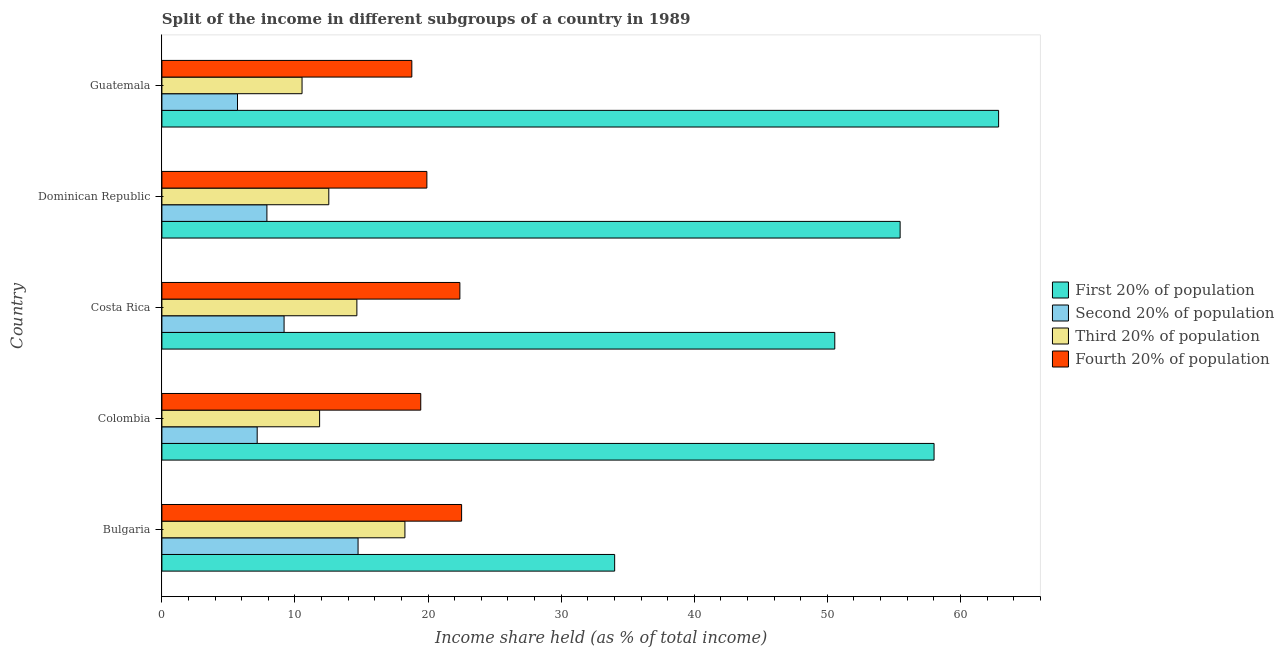How many different coloured bars are there?
Provide a succinct answer. 4. How many groups of bars are there?
Ensure brevity in your answer.  5. How many bars are there on the 4th tick from the top?
Offer a very short reply. 4. What is the label of the 1st group of bars from the top?
Provide a short and direct response. Guatemala. What is the share of the income held by second 20% of the population in Bulgaria?
Offer a terse response. 14.74. Across all countries, what is the maximum share of the income held by third 20% of the population?
Your answer should be very brief. 18.26. Across all countries, what is the minimum share of the income held by fourth 20% of the population?
Your answer should be compact. 18.78. In which country was the share of the income held by first 20% of the population maximum?
Your response must be concise. Guatemala. In which country was the share of the income held by first 20% of the population minimum?
Keep it short and to the point. Bulgaria. What is the total share of the income held by fourth 20% of the population in the graph?
Offer a very short reply. 103.05. What is the difference between the share of the income held by second 20% of the population in Bulgaria and that in Costa Rica?
Ensure brevity in your answer.  5.56. What is the difference between the share of the income held by third 20% of the population in Bulgaria and the share of the income held by fourth 20% of the population in Colombia?
Offer a very short reply. -1.19. What is the average share of the income held by fourth 20% of the population per country?
Keep it short and to the point. 20.61. What is the difference between the share of the income held by third 20% of the population and share of the income held by first 20% of the population in Guatemala?
Keep it short and to the point. -52.34. In how many countries, is the share of the income held by fourth 20% of the population greater than 44 %?
Give a very brief answer. 0. What is the ratio of the share of the income held by third 20% of the population in Dominican Republic to that in Guatemala?
Provide a short and direct response. 1.19. Is the share of the income held by first 20% of the population in Bulgaria less than that in Colombia?
Your answer should be very brief. Yes. What is the difference between the highest and the second highest share of the income held by second 20% of the population?
Your answer should be compact. 5.56. What is the difference between the highest and the lowest share of the income held by third 20% of the population?
Ensure brevity in your answer.  7.73. Is the sum of the share of the income held by first 20% of the population in Bulgaria and Colombia greater than the maximum share of the income held by third 20% of the population across all countries?
Offer a terse response. Yes. What does the 1st bar from the top in Bulgaria represents?
Make the answer very short. Fourth 20% of population. What does the 4th bar from the bottom in Colombia represents?
Your response must be concise. Fourth 20% of population. How many countries are there in the graph?
Offer a terse response. 5. What is the difference between two consecutive major ticks on the X-axis?
Offer a terse response. 10. Does the graph contain grids?
Your answer should be compact. No. Where does the legend appear in the graph?
Offer a very short reply. Center right. What is the title of the graph?
Give a very brief answer. Split of the income in different subgroups of a country in 1989. What is the label or title of the X-axis?
Your answer should be very brief. Income share held (as % of total income). What is the label or title of the Y-axis?
Offer a terse response. Country. What is the Income share held (as % of total income) of First 20% of population in Bulgaria?
Offer a terse response. 34.02. What is the Income share held (as % of total income) in Second 20% of population in Bulgaria?
Offer a terse response. 14.74. What is the Income share held (as % of total income) of Third 20% of population in Bulgaria?
Offer a very short reply. 18.26. What is the Income share held (as % of total income) of Fourth 20% of population in Bulgaria?
Your answer should be compact. 22.52. What is the Income share held (as % of total income) of First 20% of population in Colombia?
Your answer should be very brief. 58.02. What is the Income share held (as % of total income) in Second 20% of population in Colombia?
Provide a succinct answer. 7.16. What is the Income share held (as % of total income) of Third 20% of population in Colombia?
Your answer should be compact. 11.85. What is the Income share held (as % of total income) of Fourth 20% of population in Colombia?
Provide a succinct answer. 19.45. What is the Income share held (as % of total income) of First 20% of population in Costa Rica?
Your response must be concise. 50.56. What is the Income share held (as % of total income) in Second 20% of population in Costa Rica?
Your answer should be very brief. 9.18. What is the Income share held (as % of total income) in Third 20% of population in Costa Rica?
Your answer should be compact. 14.65. What is the Income share held (as % of total income) of Fourth 20% of population in Costa Rica?
Your answer should be compact. 22.39. What is the Income share held (as % of total income) in First 20% of population in Dominican Republic?
Keep it short and to the point. 55.47. What is the Income share held (as % of total income) of Second 20% of population in Dominican Republic?
Offer a terse response. 7.89. What is the Income share held (as % of total income) of Third 20% of population in Dominican Republic?
Ensure brevity in your answer.  12.54. What is the Income share held (as % of total income) in Fourth 20% of population in Dominican Republic?
Provide a short and direct response. 19.91. What is the Income share held (as % of total income) of First 20% of population in Guatemala?
Your response must be concise. 62.87. What is the Income share held (as % of total income) of Second 20% of population in Guatemala?
Give a very brief answer. 5.68. What is the Income share held (as % of total income) of Third 20% of population in Guatemala?
Keep it short and to the point. 10.53. What is the Income share held (as % of total income) of Fourth 20% of population in Guatemala?
Ensure brevity in your answer.  18.78. Across all countries, what is the maximum Income share held (as % of total income) in First 20% of population?
Keep it short and to the point. 62.87. Across all countries, what is the maximum Income share held (as % of total income) in Second 20% of population?
Provide a succinct answer. 14.74. Across all countries, what is the maximum Income share held (as % of total income) in Third 20% of population?
Your response must be concise. 18.26. Across all countries, what is the maximum Income share held (as % of total income) of Fourth 20% of population?
Your answer should be very brief. 22.52. Across all countries, what is the minimum Income share held (as % of total income) of First 20% of population?
Give a very brief answer. 34.02. Across all countries, what is the minimum Income share held (as % of total income) in Second 20% of population?
Your response must be concise. 5.68. Across all countries, what is the minimum Income share held (as % of total income) in Third 20% of population?
Your response must be concise. 10.53. Across all countries, what is the minimum Income share held (as % of total income) in Fourth 20% of population?
Provide a short and direct response. 18.78. What is the total Income share held (as % of total income) of First 20% of population in the graph?
Your answer should be compact. 260.94. What is the total Income share held (as % of total income) of Second 20% of population in the graph?
Provide a short and direct response. 44.65. What is the total Income share held (as % of total income) in Third 20% of population in the graph?
Keep it short and to the point. 67.83. What is the total Income share held (as % of total income) of Fourth 20% of population in the graph?
Your response must be concise. 103.05. What is the difference between the Income share held (as % of total income) of Second 20% of population in Bulgaria and that in Colombia?
Provide a succinct answer. 7.58. What is the difference between the Income share held (as % of total income) in Third 20% of population in Bulgaria and that in Colombia?
Give a very brief answer. 6.41. What is the difference between the Income share held (as % of total income) of Fourth 20% of population in Bulgaria and that in Colombia?
Your answer should be very brief. 3.07. What is the difference between the Income share held (as % of total income) in First 20% of population in Bulgaria and that in Costa Rica?
Your response must be concise. -16.54. What is the difference between the Income share held (as % of total income) of Second 20% of population in Bulgaria and that in Costa Rica?
Ensure brevity in your answer.  5.56. What is the difference between the Income share held (as % of total income) in Third 20% of population in Bulgaria and that in Costa Rica?
Ensure brevity in your answer.  3.61. What is the difference between the Income share held (as % of total income) of Fourth 20% of population in Bulgaria and that in Costa Rica?
Make the answer very short. 0.13. What is the difference between the Income share held (as % of total income) of First 20% of population in Bulgaria and that in Dominican Republic?
Offer a terse response. -21.45. What is the difference between the Income share held (as % of total income) in Second 20% of population in Bulgaria and that in Dominican Republic?
Your response must be concise. 6.85. What is the difference between the Income share held (as % of total income) of Third 20% of population in Bulgaria and that in Dominican Republic?
Give a very brief answer. 5.72. What is the difference between the Income share held (as % of total income) in Fourth 20% of population in Bulgaria and that in Dominican Republic?
Your response must be concise. 2.61. What is the difference between the Income share held (as % of total income) in First 20% of population in Bulgaria and that in Guatemala?
Make the answer very short. -28.85. What is the difference between the Income share held (as % of total income) of Second 20% of population in Bulgaria and that in Guatemala?
Keep it short and to the point. 9.06. What is the difference between the Income share held (as % of total income) of Third 20% of population in Bulgaria and that in Guatemala?
Your answer should be very brief. 7.73. What is the difference between the Income share held (as % of total income) in Fourth 20% of population in Bulgaria and that in Guatemala?
Keep it short and to the point. 3.74. What is the difference between the Income share held (as % of total income) in First 20% of population in Colombia and that in Costa Rica?
Ensure brevity in your answer.  7.46. What is the difference between the Income share held (as % of total income) of Second 20% of population in Colombia and that in Costa Rica?
Offer a very short reply. -2.02. What is the difference between the Income share held (as % of total income) of Third 20% of population in Colombia and that in Costa Rica?
Offer a very short reply. -2.8. What is the difference between the Income share held (as % of total income) in Fourth 20% of population in Colombia and that in Costa Rica?
Make the answer very short. -2.94. What is the difference between the Income share held (as % of total income) in First 20% of population in Colombia and that in Dominican Republic?
Provide a succinct answer. 2.55. What is the difference between the Income share held (as % of total income) of Second 20% of population in Colombia and that in Dominican Republic?
Ensure brevity in your answer.  -0.73. What is the difference between the Income share held (as % of total income) in Third 20% of population in Colombia and that in Dominican Republic?
Provide a succinct answer. -0.69. What is the difference between the Income share held (as % of total income) in Fourth 20% of population in Colombia and that in Dominican Republic?
Keep it short and to the point. -0.46. What is the difference between the Income share held (as % of total income) in First 20% of population in Colombia and that in Guatemala?
Provide a succinct answer. -4.85. What is the difference between the Income share held (as % of total income) of Second 20% of population in Colombia and that in Guatemala?
Provide a succinct answer. 1.48. What is the difference between the Income share held (as % of total income) in Third 20% of population in Colombia and that in Guatemala?
Keep it short and to the point. 1.32. What is the difference between the Income share held (as % of total income) of Fourth 20% of population in Colombia and that in Guatemala?
Your answer should be very brief. 0.67. What is the difference between the Income share held (as % of total income) in First 20% of population in Costa Rica and that in Dominican Republic?
Offer a very short reply. -4.91. What is the difference between the Income share held (as % of total income) of Second 20% of population in Costa Rica and that in Dominican Republic?
Your response must be concise. 1.29. What is the difference between the Income share held (as % of total income) of Third 20% of population in Costa Rica and that in Dominican Republic?
Keep it short and to the point. 2.11. What is the difference between the Income share held (as % of total income) of Fourth 20% of population in Costa Rica and that in Dominican Republic?
Your answer should be compact. 2.48. What is the difference between the Income share held (as % of total income) of First 20% of population in Costa Rica and that in Guatemala?
Your answer should be very brief. -12.31. What is the difference between the Income share held (as % of total income) of Second 20% of population in Costa Rica and that in Guatemala?
Your answer should be compact. 3.5. What is the difference between the Income share held (as % of total income) in Third 20% of population in Costa Rica and that in Guatemala?
Offer a terse response. 4.12. What is the difference between the Income share held (as % of total income) of Fourth 20% of population in Costa Rica and that in Guatemala?
Your answer should be compact. 3.61. What is the difference between the Income share held (as % of total income) in First 20% of population in Dominican Republic and that in Guatemala?
Your response must be concise. -7.4. What is the difference between the Income share held (as % of total income) in Second 20% of population in Dominican Republic and that in Guatemala?
Make the answer very short. 2.21. What is the difference between the Income share held (as % of total income) of Third 20% of population in Dominican Republic and that in Guatemala?
Offer a terse response. 2.01. What is the difference between the Income share held (as % of total income) in Fourth 20% of population in Dominican Republic and that in Guatemala?
Offer a very short reply. 1.13. What is the difference between the Income share held (as % of total income) of First 20% of population in Bulgaria and the Income share held (as % of total income) of Second 20% of population in Colombia?
Offer a very short reply. 26.86. What is the difference between the Income share held (as % of total income) of First 20% of population in Bulgaria and the Income share held (as % of total income) of Third 20% of population in Colombia?
Your answer should be very brief. 22.17. What is the difference between the Income share held (as % of total income) in First 20% of population in Bulgaria and the Income share held (as % of total income) in Fourth 20% of population in Colombia?
Give a very brief answer. 14.57. What is the difference between the Income share held (as % of total income) in Second 20% of population in Bulgaria and the Income share held (as % of total income) in Third 20% of population in Colombia?
Ensure brevity in your answer.  2.89. What is the difference between the Income share held (as % of total income) in Second 20% of population in Bulgaria and the Income share held (as % of total income) in Fourth 20% of population in Colombia?
Offer a very short reply. -4.71. What is the difference between the Income share held (as % of total income) of Third 20% of population in Bulgaria and the Income share held (as % of total income) of Fourth 20% of population in Colombia?
Your answer should be compact. -1.19. What is the difference between the Income share held (as % of total income) in First 20% of population in Bulgaria and the Income share held (as % of total income) in Second 20% of population in Costa Rica?
Give a very brief answer. 24.84. What is the difference between the Income share held (as % of total income) of First 20% of population in Bulgaria and the Income share held (as % of total income) of Third 20% of population in Costa Rica?
Your response must be concise. 19.37. What is the difference between the Income share held (as % of total income) in First 20% of population in Bulgaria and the Income share held (as % of total income) in Fourth 20% of population in Costa Rica?
Your answer should be very brief. 11.63. What is the difference between the Income share held (as % of total income) of Second 20% of population in Bulgaria and the Income share held (as % of total income) of Third 20% of population in Costa Rica?
Offer a terse response. 0.09. What is the difference between the Income share held (as % of total income) in Second 20% of population in Bulgaria and the Income share held (as % of total income) in Fourth 20% of population in Costa Rica?
Provide a short and direct response. -7.65. What is the difference between the Income share held (as % of total income) in Third 20% of population in Bulgaria and the Income share held (as % of total income) in Fourth 20% of population in Costa Rica?
Your answer should be compact. -4.13. What is the difference between the Income share held (as % of total income) in First 20% of population in Bulgaria and the Income share held (as % of total income) in Second 20% of population in Dominican Republic?
Ensure brevity in your answer.  26.13. What is the difference between the Income share held (as % of total income) of First 20% of population in Bulgaria and the Income share held (as % of total income) of Third 20% of population in Dominican Republic?
Your answer should be very brief. 21.48. What is the difference between the Income share held (as % of total income) of First 20% of population in Bulgaria and the Income share held (as % of total income) of Fourth 20% of population in Dominican Republic?
Ensure brevity in your answer.  14.11. What is the difference between the Income share held (as % of total income) of Second 20% of population in Bulgaria and the Income share held (as % of total income) of Third 20% of population in Dominican Republic?
Your answer should be compact. 2.2. What is the difference between the Income share held (as % of total income) in Second 20% of population in Bulgaria and the Income share held (as % of total income) in Fourth 20% of population in Dominican Republic?
Provide a short and direct response. -5.17. What is the difference between the Income share held (as % of total income) in Third 20% of population in Bulgaria and the Income share held (as % of total income) in Fourth 20% of population in Dominican Republic?
Provide a short and direct response. -1.65. What is the difference between the Income share held (as % of total income) of First 20% of population in Bulgaria and the Income share held (as % of total income) of Second 20% of population in Guatemala?
Make the answer very short. 28.34. What is the difference between the Income share held (as % of total income) in First 20% of population in Bulgaria and the Income share held (as % of total income) in Third 20% of population in Guatemala?
Give a very brief answer. 23.49. What is the difference between the Income share held (as % of total income) of First 20% of population in Bulgaria and the Income share held (as % of total income) of Fourth 20% of population in Guatemala?
Make the answer very short. 15.24. What is the difference between the Income share held (as % of total income) of Second 20% of population in Bulgaria and the Income share held (as % of total income) of Third 20% of population in Guatemala?
Offer a very short reply. 4.21. What is the difference between the Income share held (as % of total income) in Second 20% of population in Bulgaria and the Income share held (as % of total income) in Fourth 20% of population in Guatemala?
Provide a short and direct response. -4.04. What is the difference between the Income share held (as % of total income) in Third 20% of population in Bulgaria and the Income share held (as % of total income) in Fourth 20% of population in Guatemala?
Make the answer very short. -0.52. What is the difference between the Income share held (as % of total income) of First 20% of population in Colombia and the Income share held (as % of total income) of Second 20% of population in Costa Rica?
Ensure brevity in your answer.  48.84. What is the difference between the Income share held (as % of total income) of First 20% of population in Colombia and the Income share held (as % of total income) of Third 20% of population in Costa Rica?
Provide a short and direct response. 43.37. What is the difference between the Income share held (as % of total income) in First 20% of population in Colombia and the Income share held (as % of total income) in Fourth 20% of population in Costa Rica?
Ensure brevity in your answer.  35.63. What is the difference between the Income share held (as % of total income) in Second 20% of population in Colombia and the Income share held (as % of total income) in Third 20% of population in Costa Rica?
Give a very brief answer. -7.49. What is the difference between the Income share held (as % of total income) of Second 20% of population in Colombia and the Income share held (as % of total income) of Fourth 20% of population in Costa Rica?
Give a very brief answer. -15.23. What is the difference between the Income share held (as % of total income) in Third 20% of population in Colombia and the Income share held (as % of total income) in Fourth 20% of population in Costa Rica?
Provide a short and direct response. -10.54. What is the difference between the Income share held (as % of total income) in First 20% of population in Colombia and the Income share held (as % of total income) in Second 20% of population in Dominican Republic?
Offer a terse response. 50.13. What is the difference between the Income share held (as % of total income) in First 20% of population in Colombia and the Income share held (as % of total income) in Third 20% of population in Dominican Republic?
Keep it short and to the point. 45.48. What is the difference between the Income share held (as % of total income) in First 20% of population in Colombia and the Income share held (as % of total income) in Fourth 20% of population in Dominican Republic?
Provide a short and direct response. 38.11. What is the difference between the Income share held (as % of total income) in Second 20% of population in Colombia and the Income share held (as % of total income) in Third 20% of population in Dominican Republic?
Your answer should be compact. -5.38. What is the difference between the Income share held (as % of total income) of Second 20% of population in Colombia and the Income share held (as % of total income) of Fourth 20% of population in Dominican Republic?
Give a very brief answer. -12.75. What is the difference between the Income share held (as % of total income) of Third 20% of population in Colombia and the Income share held (as % of total income) of Fourth 20% of population in Dominican Republic?
Make the answer very short. -8.06. What is the difference between the Income share held (as % of total income) in First 20% of population in Colombia and the Income share held (as % of total income) in Second 20% of population in Guatemala?
Your response must be concise. 52.34. What is the difference between the Income share held (as % of total income) in First 20% of population in Colombia and the Income share held (as % of total income) in Third 20% of population in Guatemala?
Your answer should be very brief. 47.49. What is the difference between the Income share held (as % of total income) in First 20% of population in Colombia and the Income share held (as % of total income) in Fourth 20% of population in Guatemala?
Offer a terse response. 39.24. What is the difference between the Income share held (as % of total income) in Second 20% of population in Colombia and the Income share held (as % of total income) in Third 20% of population in Guatemala?
Give a very brief answer. -3.37. What is the difference between the Income share held (as % of total income) of Second 20% of population in Colombia and the Income share held (as % of total income) of Fourth 20% of population in Guatemala?
Your response must be concise. -11.62. What is the difference between the Income share held (as % of total income) in Third 20% of population in Colombia and the Income share held (as % of total income) in Fourth 20% of population in Guatemala?
Your answer should be very brief. -6.93. What is the difference between the Income share held (as % of total income) in First 20% of population in Costa Rica and the Income share held (as % of total income) in Second 20% of population in Dominican Republic?
Provide a short and direct response. 42.67. What is the difference between the Income share held (as % of total income) of First 20% of population in Costa Rica and the Income share held (as % of total income) of Third 20% of population in Dominican Republic?
Your answer should be very brief. 38.02. What is the difference between the Income share held (as % of total income) in First 20% of population in Costa Rica and the Income share held (as % of total income) in Fourth 20% of population in Dominican Republic?
Ensure brevity in your answer.  30.65. What is the difference between the Income share held (as % of total income) of Second 20% of population in Costa Rica and the Income share held (as % of total income) of Third 20% of population in Dominican Republic?
Your answer should be compact. -3.36. What is the difference between the Income share held (as % of total income) of Second 20% of population in Costa Rica and the Income share held (as % of total income) of Fourth 20% of population in Dominican Republic?
Your response must be concise. -10.73. What is the difference between the Income share held (as % of total income) of Third 20% of population in Costa Rica and the Income share held (as % of total income) of Fourth 20% of population in Dominican Republic?
Your answer should be very brief. -5.26. What is the difference between the Income share held (as % of total income) of First 20% of population in Costa Rica and the Income share held (as % of total income) of Second 20% of population in Guatemala?
Provide a short and direct response. 44.88. What is the difference between the Income share held (as % of total income) in First 20% of population in Costa Rica and the Income share held (as % of total income) in Third 20% of population in Guatemala?
Give a very brief answer. 40.03. What is the difference between the Income share held (as % of total income) of First 20% of population in Costa Rica and the Income share held (as % of total income) of Fourth 20% of population in Guatemala?
Offer a very short reply. 31.78. What is the difference between the Income share held (as % of total income) of Second 20% of population in Costa Rica and the Income share held (as % of total income) of Third 20% of population in Guatemala?
Give a very brief answer. -1.35. What is the difference between the Income share held (as % of total income) in Second 20% of population in Costa Rica and the Income share held (as % of total income) in Fourth 20% of population in Guatemala?
Offer a terse response. -9.6. What is the difference between the Income share held (as % of total income) of Third 20% of population in Costa Rica and the Income share held (as % of total income) of Fourth 20% of population in Guatemala?
Offer a terse response. -4.13. What is the difference between the Income share held (as % of total income) in First 20% of population in Dominican Republic and the Income share held (as % of total income) in Second 20% of population in Guatemala?
Make the answer very short. 49.79. What is the difference between the Income share held (as % of total income) of First 20% of population in Dominican Republic and the Income share held (as % of total income) of Third 20% of population in Guatemala?
Give a very brief answer. 44.94. What is the difference between the Income share held (as % of total income) of First 20% of population in Dominican Republic and the Income share held (as % of total income) of Fourth 20% of population in Guatemala?
Offer a terse response. 36.69. What is the difference between the Income share held (as % of total income) of Second 20% of population in Dominican Republic and the Income share held (as % of total income) of Third 20% of population in Guatemala?
Give a very brief answer. -2.64. What is the difference between the Income share held (as % of total income) of Second 20% of population in Dominican Republic and the Income share held (as % of total income) of Fourth 20% of population in Guatemala?
Provide a short and direct response. -10.89. What is the difference between the Income share held (as % of total income) in Third 20% of population in Dominican Republic and the Income share held (as % of total income) in Fourth 20% of population in Guatemala?
Provide a succinct answer. -6.24. What is the average Income share held (as % of total income) in First 20% of population per country?
Ensure brevity in your answer.  52.19. What is the average Income share held (as % of total income) in Second 20% of population per country?
Offer a terse response. 8.93. What is the average Income share held (as % of total income) of Third 20% of population per country?
Make the answer very short. 13.57. What is the average Income share held (as % of total income) of Fourth 20% of population per country?
Make the answer very short. 20.61. What is the difference between the Income share held (as % of total income) in First 20% of population and Income share held (as % of total income) in Second 20% of population in Bulgaria?
Offer a terse response. 19.28. What is the difference between the Income share held (as % of total income) in First 20% of population and Income share held (as % of total income) in Third 20% of population in Bulgaria?
Your answer should be compact. 15.76. What is the difference between the Income share held (as % of total income) of First 20% of population and Income share held (as % of total income) of Fourth 20% of population in Bulgaria?
Give a very brief answer. 11.5. What is the difference between the Income share held (as % of total income) in Second 20% of population and Income share held (as % of total income) in Third 20% of population in Bulgaria?
Your answer should be compact. -3.52. What is the difference between the Income share held (as % of total income) of Second 20% of population and Income share held (as % of total income) of Fourth 20% of population in Bulgaria?
Your answer should be very brief. -7.78. What is the difference between the Income share held (as % of total income) in Third 20% of population and Income share held (as % of total income) in Fourth 20% of population in Bulgaria?
Your response must be concise. -4.26. What is the difference between the Income share held (as % of total income) of First 20% of population and Income share held (as % of total income) of Second 20% of population in Colombia?
Offer a terse response. 50.86. What is the difference between the Income share held (as % of total income) in First 20% of population and Income share held (as % of total income) in Third 20% of population in Colombia?
Make the answer very short. 46.17. What is the difference between the Income share held (as % of total income) in First 20% of population and Income share held (as % of total income) in Fourth 20% of population in Colombia?
Offer a very short reply. 38.57. What is the difference between the Income share held (as % of total income) of Second 20% of population and Income share held (as % of total income) of Third 20% of population in Colombia?
Offer a very short reply. -4.69. What is the difference between the Income share held (as % of total income) of Second 20% of population and Income share held (as % of total income) of Fourth 20% of population in Colombia?
Offer a very short reply. -12.29. What is the difference between the Income share held (as % of total income) of First 20% of population and Income share held (as % of total income) of Second 20% of population in Costa Rica?
Ensure brevity in your answer.  41.38. What is the difference between the Income share held (as % of total income) of First 20% of population and Income share held (as % of total income) of Third 20% of population in Costa Rica?
Ensure brevity in your answer.  35.91. What is the difference between the Income share held (as % of total income) of First 20% of population and Income share held (as % of total income) of Fourth 20% of population in Costa Rica?
Give a very brief answer. 28.17. What is the difference between the Income share held (as % of total income) of Second 20% of population and Income share held (as % of total income) of Third 20% of population in Costa Rica?
Ensure brevity in your answer.  -5.47. What is the difference between the Income share held (as % of total income) of Second 20% of population and Income share held (as % of total income) of Fourth 20% of population in Costa Rica?
Offer a very short reply. -13.21. What is the difference between the Income share held (as % of total income) of Third 20% of population and Income share held (as % of total income) of Fourth 20% of population in Costa Rica?
Offer a terse response. -7.74. What is the difference between the Income share held (as % of total income) in First 20% of population and Income share held (as % of total income) in Second 20% of population in Dominican Republic?
Ensure brevity in your answer.  47.58. What is the difference between the Income share held (as % of total income) of First 20% of population and Income share held (as % of total income) of Third 20% of population in Dominican Republic?
Your answer should be very brief. 42.93. What is the difference between the Income share held (as % of total income) of First 20% of population and Income share held (as % of total income) of Fourth 20% of population in Dominican Republic?
Give a very brief answer. 35.56. What is the difference between the Income share held (as % of total income) in Second 20% of population and Income share held (as % of total income) in Third 20% of population in Dominican Republic?
Provide a short and direct response. -4.65. What is the difference between the Income share held (as % of total income) of Second 20% of population and Income share held (as % of total income) of Fourth 20% of population in Dominican Republic?
Give a very brief answer. -12.02. What is the difference between the Income share held (as % of total income) in Third 20% of population and Income share held (as % of total income) in Fourth 20% of population in Dominican Republic?
Your response must be concise. -7.37. What is the difference between the Income share held (as % of total income) of First 20% of population and Income share held (as % of total income) of Second 20% of population in Guatemala?
Your response must be concise. 57.19. What is the difference between the Income share held (as % of total income) of First 20% of population and Income share held (as % of total income) of Third 20% of population in Guatemala?
Ensure brevity in your answer.  52.34. What is the difference between the Income share held (as % of total income) in First 20% of population and Income share held (as % of total income) in Fourth 20% of population in Guatemala?
Ensure brevity in your answer.  44.09. What is the difference between the Income share held (as % of total income) in Second 20% of population and Income share held (as % of total income) in Third 20% of population in Guatemala?
Offer a terse response. -4.85. What is the difference between the Income share held (as % of total income) in Second 20% of population and Income share held (as % of total income) in Fourth 20% of population in Guatemala?
Your answer should be compact. -13.1. What is the difference between the Income share held (as % of total income) of Third 20% of population and Income share held (as % of total income) of Fourth 20% of population in Guatemala?
Make the answer very short. -8.25. What is the ratio of the Income share held (as % of total income) of First 20% of population in Bulgaria to that in Colombia?
Keep it short and to the point. 0.59. What is the ratio of the Income share held (as % of total income) in Second 20% of population in Bulgaria to that in Colombia?
Your answer should be very brief. 2.06. What is the ratio of the Income share held (as % of total income) of Third 20% of population in Bulgaria to that in Colombia?
Your answer should be compact. 1.54. What is the ratio of the Income share held (as % of total income) of Fourth 20% of population in Bulgaria to that in Colombia?
Ensure brevity in your answer.  1.16. What is the ratio of the Income share held (as % of total income) in First 20% of population in Bulgaria to that in Costa Rica?
Make the answer very short. 0.67. What is the ratio of the Income share held (as % of total income) of Second 20% of population in Bulgaria to that in Costa Rica?
Your response must be concise. 1.61. What is the ratio of the Income share held (as % of total income) of Third 20% of population in Bulgaria to that in Costa Rica?
Keep it short and to the point. 1.25. What is the ratio of the Income share held (as % of total income) of First 20% of population in Bulgaria to that in Dominican Republic?
Offer a very short reply. 0.61. What is the ratio of the Income share held (as % of total income) of Second 20% of population in Bulgaria to that in Dominican Republic?
Offer a very short reply. 1.87. What is the ratio of the Income share held (as % of total income) of Third 20% of population in Bulgaria to that in Dominican Republic?
Give a very brief answer. 1.46. What is the ratio of the Income share held (as % of total income) of Fourth 20% of population in Bulgaria to that in Dominican Republic?
Keep it short and to the point. 1.13. What is the ratio of the Income share held (as % of total income) of First 20% of population in Bulgaria to that in Guatemala?
Your response must be concise. 0.54. What is the ratio of the Income share held (as % of total income) of Second 20% of population in Bulgaria to that in Guatemala?
Provide a succinct answer. 2.6. What is the ratio of the Income share held (as % of total income) of Third 20% of population in Bulgaria to that in Guatemala?
Offer a terse response. 1.73. What is the ratio of the Income share held (as % of total income) of Fourth 20% of population in Bulgaria to that in Guatemala?
Give a very brief answer. 1.2. What is the ratio of the Income share held (as % of total income) in First 20% of population in Colombia to that in Costa Rica?
Make the answer very short. 1.15. What is the ratio of the Income share held (as % of total income) of Second 20% of population in Colombia to that in Costa Rica?
Provide a succinct answer. 0.78. What is the ratio of the Income share held (as % of total income) in Third 20% of population in Colombia to that in Costa Rica?
Provide a succinct answer. 0.81. What is the ratio of the Income share held (as % of total income) in Fourth 20% of population in Colombia to that in Costa Rica?
Offer a very short reply. 0.87. What is the ratio of the Income share held (as % of total income) in First 20% of population in Colombia to that in Dominican Republic?
Ensure brevity in your answer.  1.05. What is the ratio of the Income share held (as % of total income) in Second 20% of population in Colombia to that in Dominican Republic?
Your answer should be compact. 0.91. What is the ratio of the Income share held (as % of total income) of Third 20% of population in Colombia to that in Dominican Republic?
Make the answer very short. 0.94. What is the ratio of the Income share held (as % of total income) in Fourth 20% of population in Colombia to that in Dominican Republic?
Give a very brief answer. 0.98. What is the ratio of the Income share held (as % of total income) in First 20% of population in Colombia to that in Guatemala?
Your answer should be very brief. 0.92. What is the ratio of the Income share held (as % of total income) of Second 20% of population in Colombia to that in Guatemala?
Offer a very short reply. 1.26. What is the ratio of the Income share held (as % of total income) of Third 20% of population in Colombia to that in Guatemala?
Provide a short and direct response. 1.13. What is the ratio of the Income share held (as % of total income) in Fourth 20% of population in Colombia to that in Guatemala?
Your response must be concise. 1.04. What is the ratio of the Income share held (as % of total income) of First 20% of population in Costa Rica to that in Dominican Republic?
Provide a succinct answer. 0.91. What is the ratio of the Income share held (as % of total income) of Second 20% of population in Costa Rica to that in Dominican Republic?
Keep it short and to the point. 1.16. What is the ratio of the Income share held (as % of total income) of Third 20% of population in Costa Rica to that in Dominican Republic?
Your answer should be compact. 1.17. What is the ratio of the Income share held (as % of total income) of Fourth 20% of population in Costa Rica to that in Dominican Republic?
Your answer should be very brief. 1.12. What is the ratio of the Income share held (as % of total income) in First 20% of population in Costa Rica to that in Guatemala?
Provide a succinct answer. 0.8. What is the ratio of the Income share held (as % of total income) in Second 20% of population in Costa Rica to that in Guatemala?
Offer a terse response. 1.62. What is the ratio of the Income share held (as % of total income) of Third 20% of population in Costa Rica to that in Guatemala?
Your answer should be very brief. 1.39. What is the ratio of the Income share held (as % of total income) in Fourth 20% of population in Costa Rica to that in Guatemala?
Provide a short and direct response. 1.19. What is the ratio of the Income share held (as % of total income) of First 20% of population in Dominican Republic to that in Guatemala?
Offer a very short reply. 0.88. What is the ratio of the Income share held (as % of total income) in Second 20% of population in Dominican Republic to that in Guatemala?
Give a very brief answer. 1.39. What is the ratio of the Income share held (as % of total income) of Third 20% of population in Dominican Republic to that in Guatemala?
Offer a terse response. 1.19. What is the ratio of the Income share held (as % of total income) of Fourth 20% of population in Dominican Republic to that in Guatemala?
Your answer should be compact. 1.06. What is the difference between the highest and the second highest Income share held (as % of total income) of First 20% of population?
Your answer should be very brief. 4.85. What is the difference between the highest and the second highest Income share held (as % of total income) of Second 20% of population?
Offer a very short reply. 5.56. What is the difference between the highest and the second highest Income share held (as % of total income) of Third 20% of population?
Make the answer very short. 3.61. What is the difference between the highest and the second highest Income share held (as % of total income) in Fourth 20% of population?
Give a very brief answer. 0.13. What is the difference between the highest and the lowest Income share held (as % of total income) of First 20% of population?
Your answer should be compact. 28.85. What is the difference between the highest and the lowest Income share held (as % of total income) in Second 20% of population?
Offer a terse response. 9.06. What is the difference between the highest and the lowest Income share held (as % of total income) of Third 20% of population?
Your answer should be compact. 7.73. What is the difference between the highest and the lowest Income share held (as % of total income) in Fourth 20% of population?
Offer a very short reply. 3.74. 